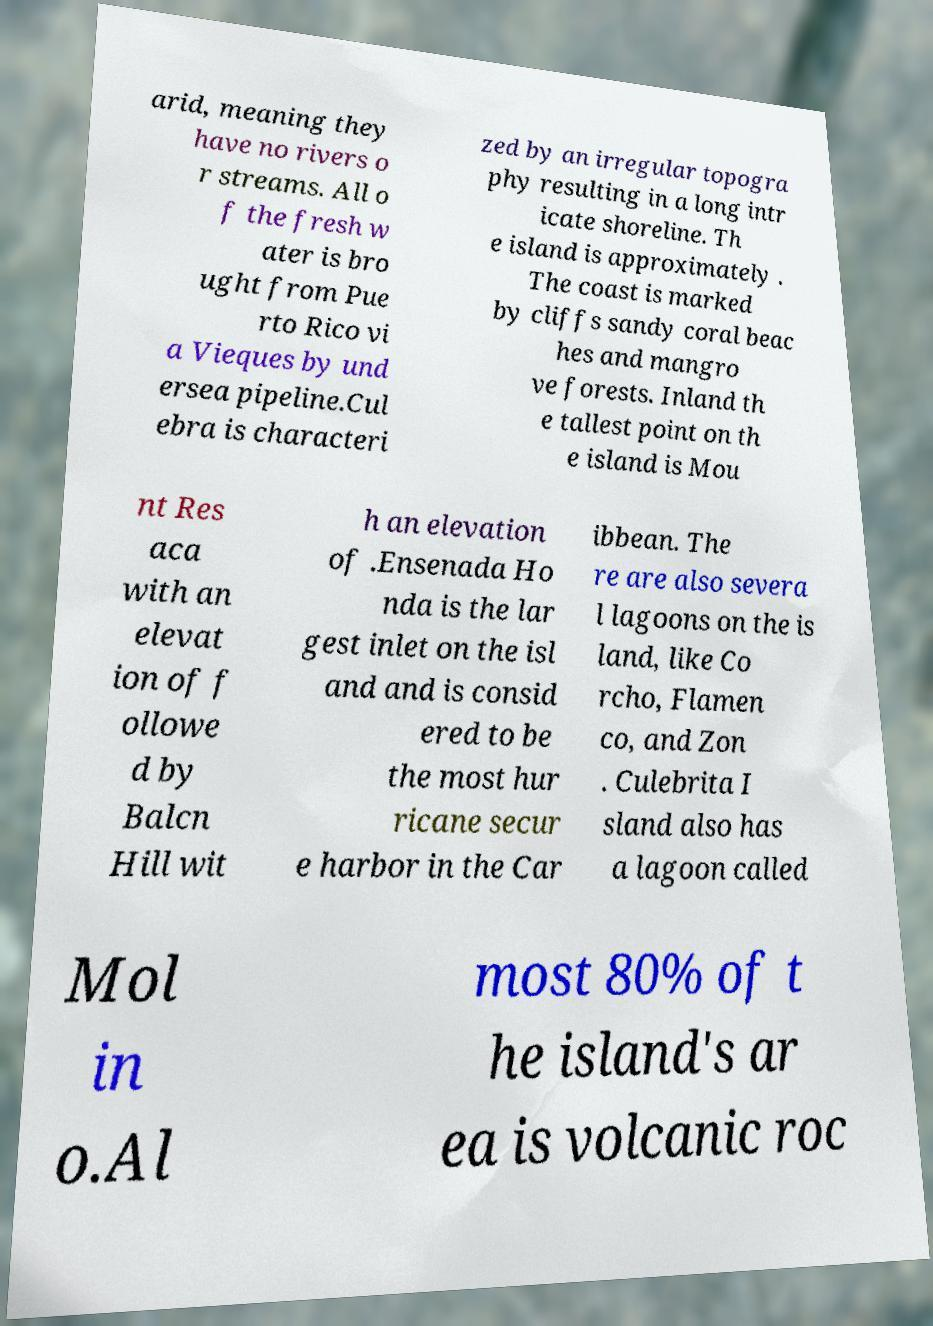Can you accurately transcribe the text from the provided image for me? arid, meaning they have no rivers o r streams. All o f the fresh w ater is bro ught from Pue rto Rico vi a Vieques by und ersea pipeline.Cul ebra is characteri zed by an irregular topogra phy resulting in a long intr icate shoreline. Th e island is approximately . The coast is marked by cliffs sandy coral beac hes and mangro ve forests. Inland th e tallest point on th e island is Mou nt Res aca with an elevat ion of f ollowe d by Balcn Hill wit h an elevation of .Ensenada Ho nda is the lar gest inlet on the isl and and is consid ered to be the most hur ricane secur e harbor in the Car ibbean. The re are also severa l lagoons on the is land, like Co rcho, Flamen co, and Zon . Culebrita I sland also has a lagoon called Mol in o.Al most 80% of t he island's ar ea is volcanic roc 